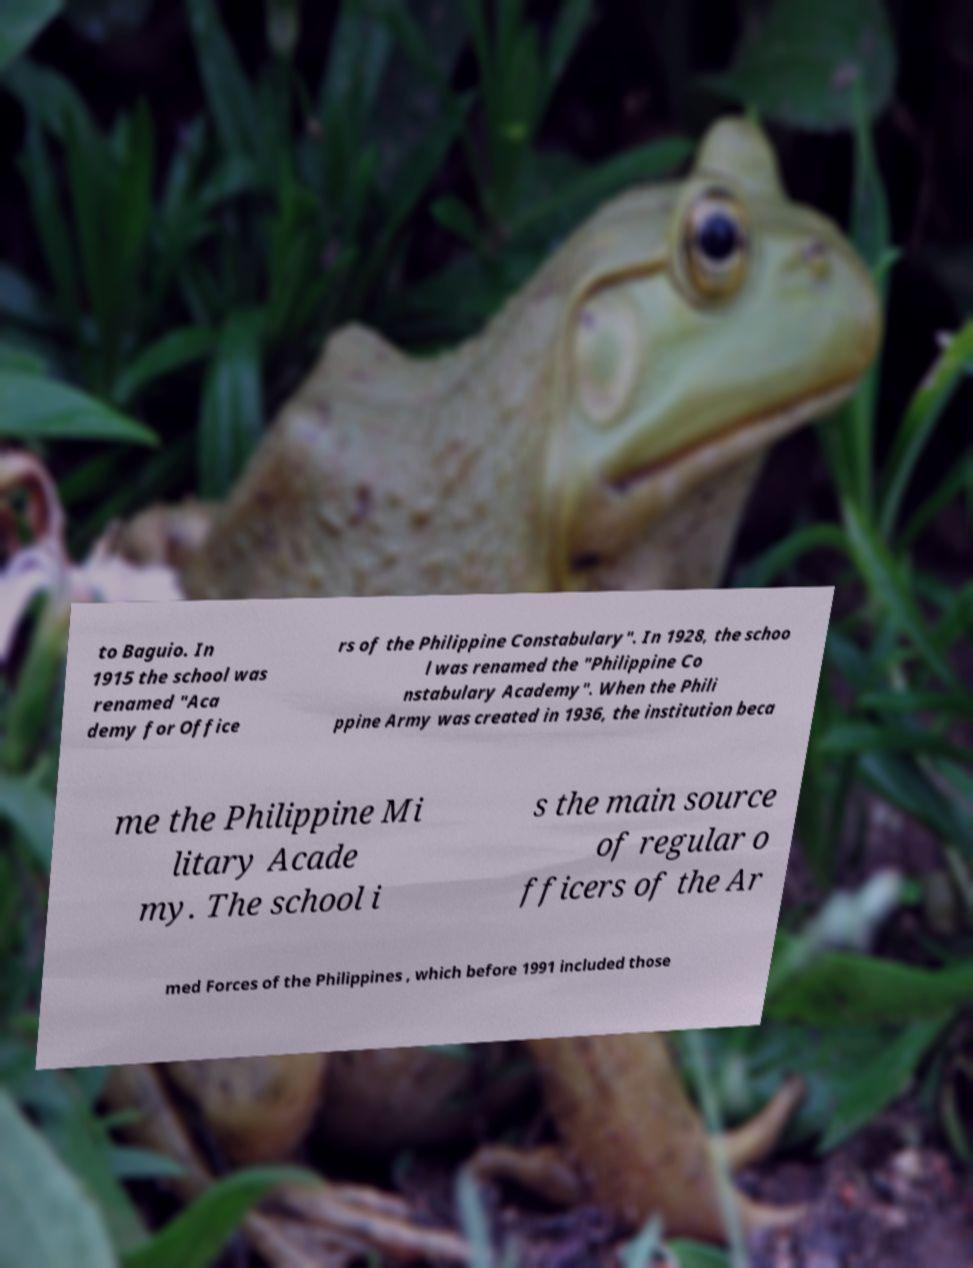What messages or text are displayed in this image? I need them in a readable, typed format. to Baguio. In 1915 the school was renamed "Aca demy for Office rs of the Philippine Constabulary". In 1928, the schoo l was renamed the "Philippine Co nstabulary Academy". When the Phili ppine Army was created in 1936, the institution beca me the Philippine Mi litary Acade my. The school i s the main source of regular o fficers of the Ar med Forces of the Philippines , which before 1991 included those 